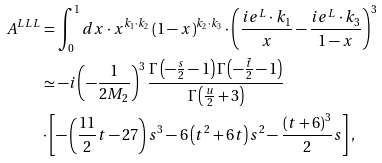<formula> <loc_0><loc_0><loc_500><loc_500>A ^ { L L L } & = \int _ { 0 } ^ { 1 } d x \cdot x ^ { k _ { 1 } \cdot k _ { 2 } } \left ( 1 - x \right ) ^ { k _ { 2 } \cdot k _ { 3 } } \cdot \left ( \frac { i e ^ { L } \cdot k _ { 1 } } { x } - \frac { i e ^ { L } \cdot k _ { 3 } } { 1 - x } \right ) ^ { 3 } \\ & \simeq - i \left ( - \frac { 1 } { 2 M _ { 2 } } \right ) ^ { 3 } \frac { \Gamma \left ( - \frac { s } { 2 } - 1 \right ) \Gamma \left ( - \frac { \tilde { t } } { 2 } - 1 \right ) } { \Gamma \left ( \frac { u } { 2 } + 3 \right ) } \\ & \cdot \left [ - \left ( \frac { 1 1 } { 2 } t - 2 7 \right ) s ^ { 3 } - 6 \left ( t ^ { 2 } + 6 t \right ) s ^ { 2 } - \frac { \left ( t + 6 \right ) ^ { 3 } } { 2 } s \right ] ,</formula> 